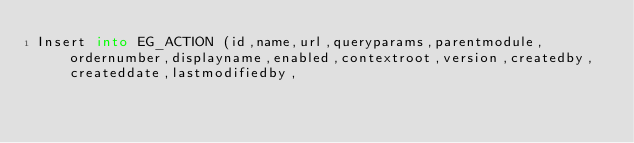Convert code to text. <code><loc_0><loc_0><loc_500><loc_500><_SQL_>Insert into EG_ACTION (id,name,url,queryparams,parentmodule,ordernumber,displayname,enabled,contextroot,version,createdby,createddate,lastmodifiedby,</code> 